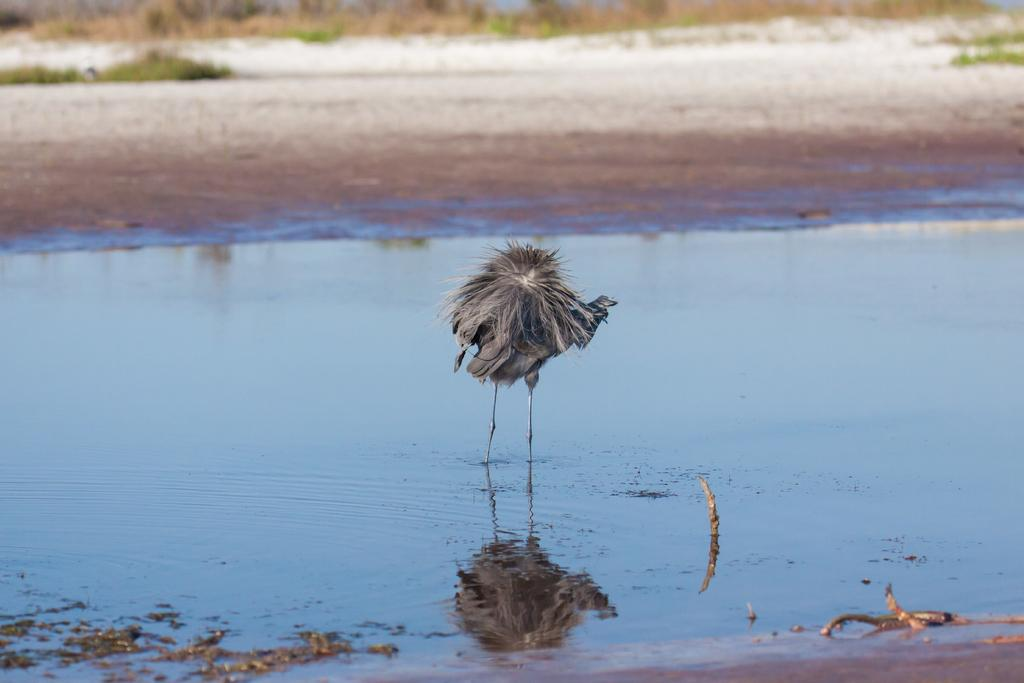What type of animal can be seen in the water in the image? There is a bird in the water in the image. What can be seen in the background of the image? There are plants visible in the background. Where is the toothbrush located in the image? There is no toothbrush present in the image. How many mice can be seen in the image? There are no mice present in the image. 